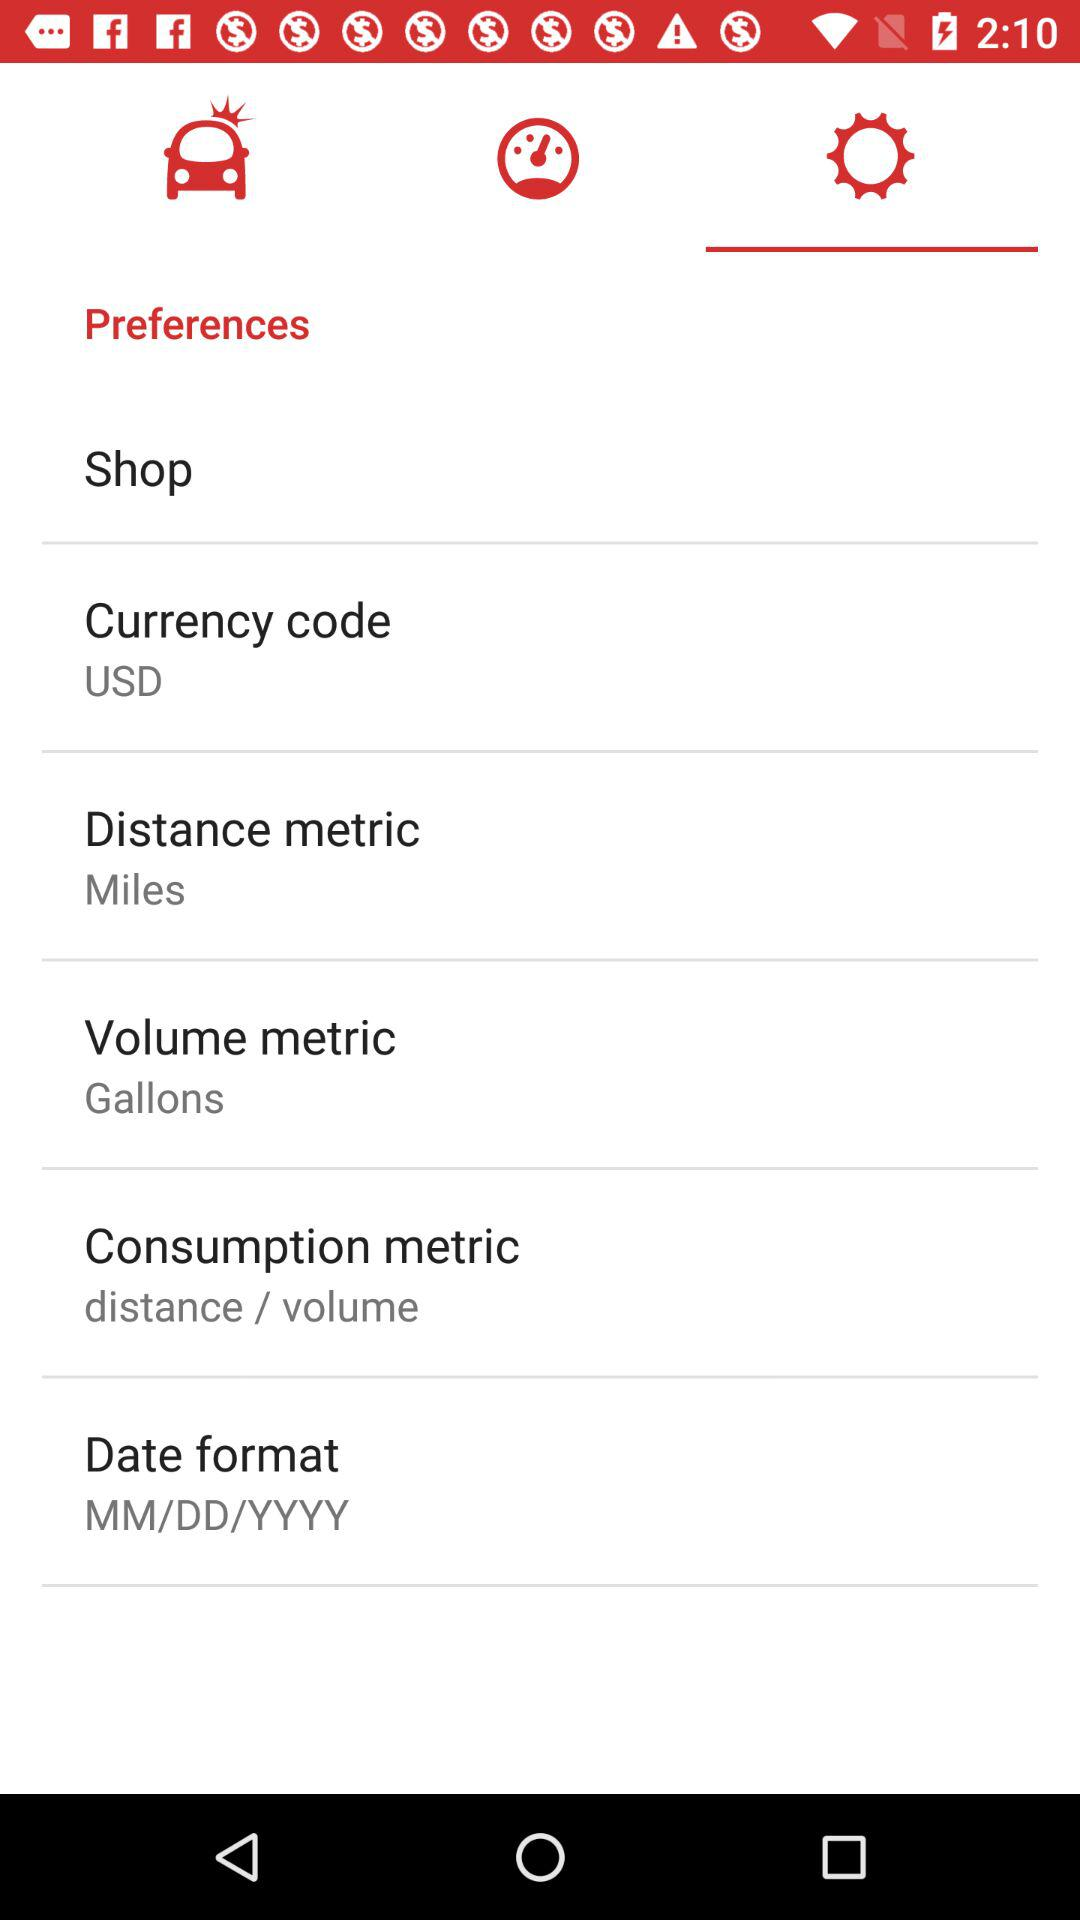What is the setting for "Consumption metric"? The setting for "Consumption metric" is "distance / volume". 